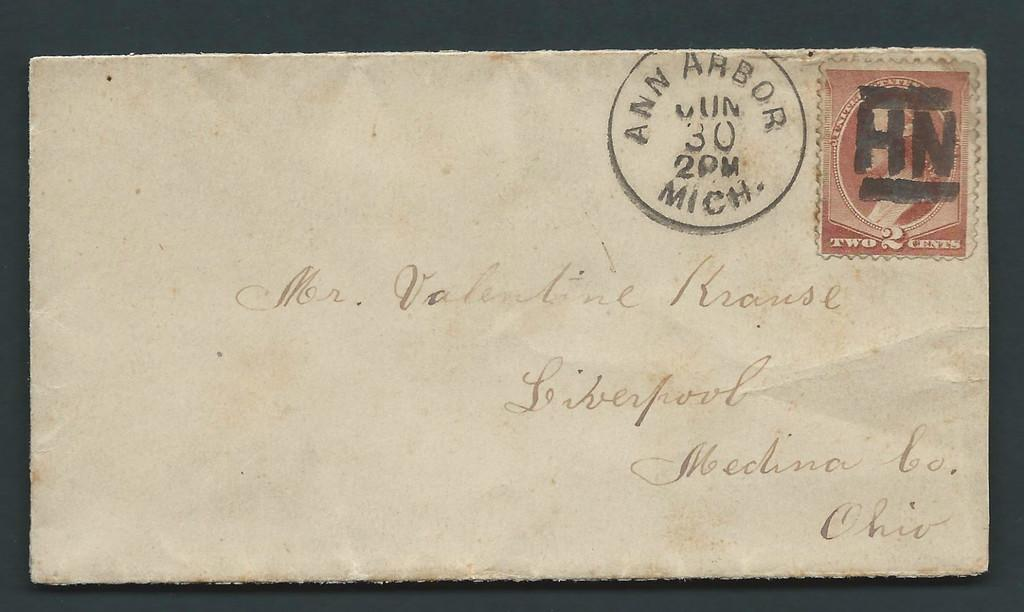<image>
Offer a succinct explanation of the picture presented. an envelope with a cancel stamp from Ann Arbor Mich on the 30 at 2pm 